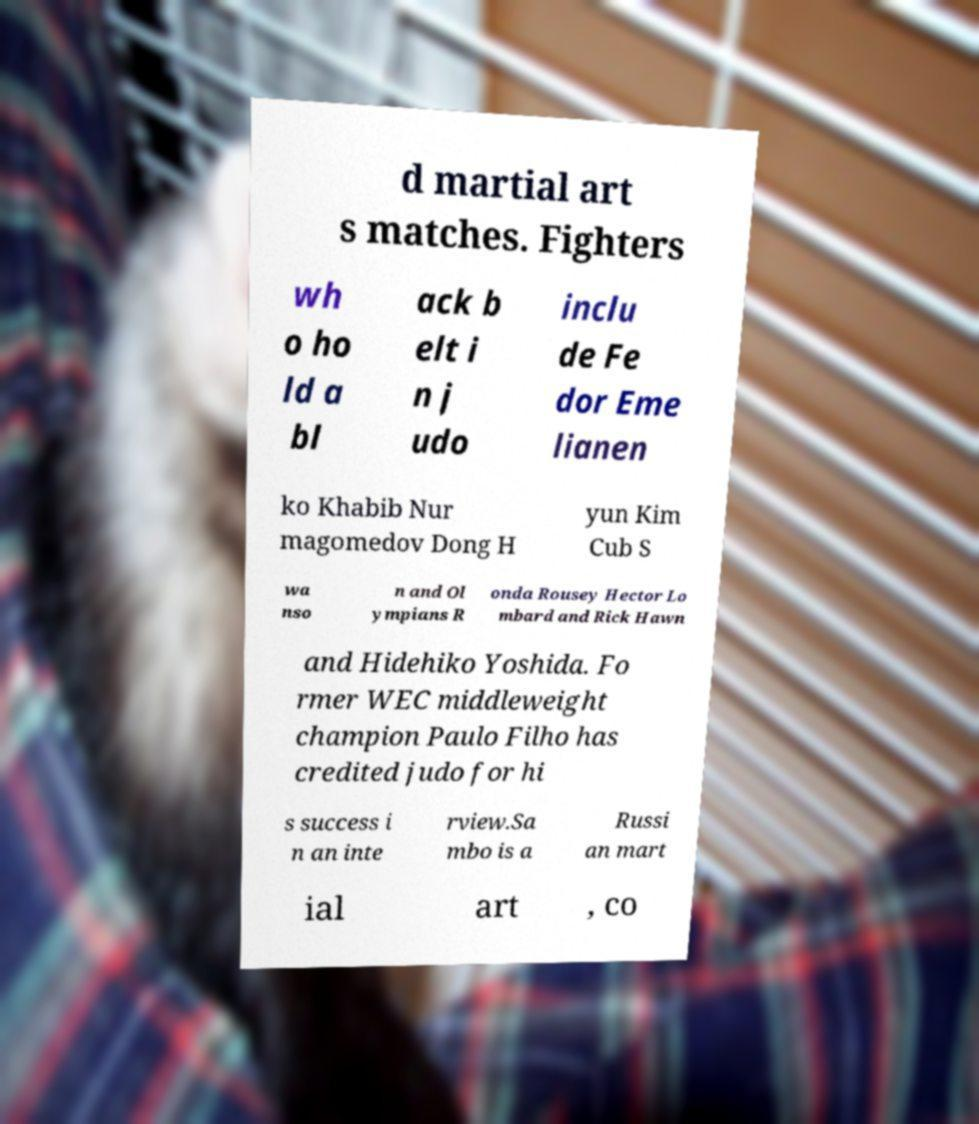I need the written content from this picture converted into text. Can you do that? d martial art s matches. Fighters wh o ho ld a bl ack b elt i n j udo inclu de Fe dor Eme lianen ko Khabib Nur magomedov Dong H yun Kim Cub S wa nso n and Ol ympians R onda Rousey Hector Lo mbard and Rick Hawn and Hidehiko Yoshida. Fo rmer WEC middleweight champion Paulo Filho has credited judo for hi s success i n an inte rview.Sa mbo is a Russi an mart ial art , co 